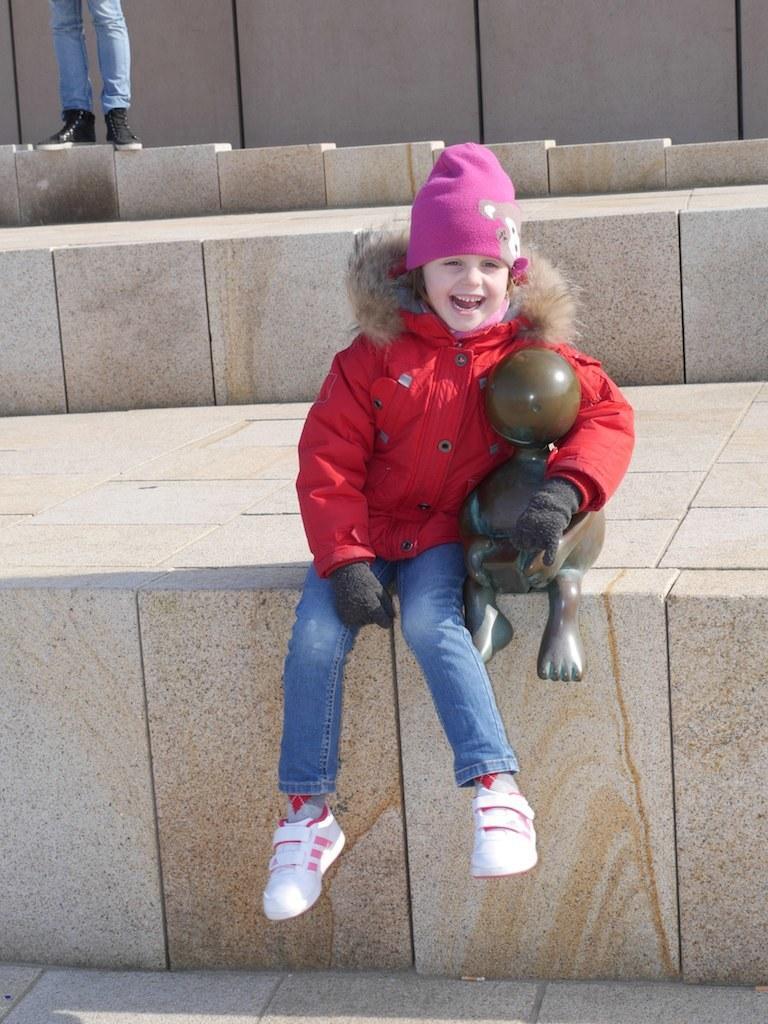In one or two sentences, can you explain what this image depicts? In the picture there is a girl sitting beside a statue and laughing, behind the girl there is a person standing. 